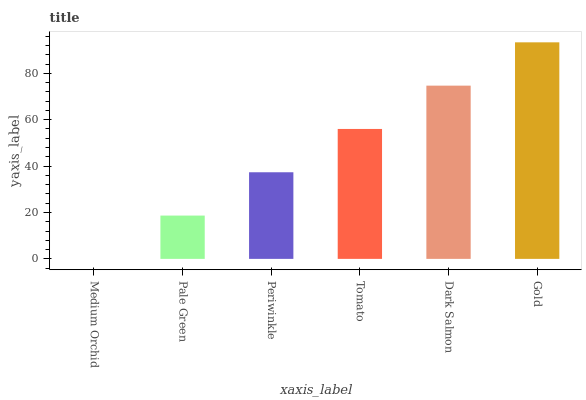Is Medium Orchid the minimum?
Answer yes or no. Yes. Is Gold the maximum?
Answer yes or no. Yes. Is Pale Green the minimum?
Answer yes or no. No. Is Pale Green the maximum?
Answer yes or no. No. Is Pale Green greater than Medium Orchid?
Answer yes or no. Yes. Is Medium Orchid less than Pale Green?
Answer yes or no. Yes. Is Medium Orchid greater than Pale Green?
Answer yes or no. No. Is Pale Green less than Medium Orchid?
Answer yes or no. No. Is Tomato the high median?
Answer yes or no. Yes. Is Periwinkle the low median?
Answer yes or no. Yes. Is Pale Green the high median?
Answer yes or no. No. Is Medium Orchid the low median?
Answer yes or no. No. 